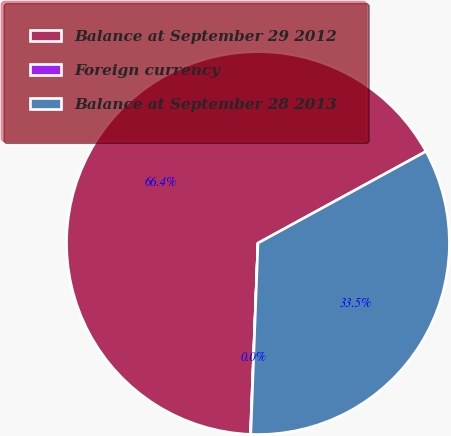Convert chart to OTSL. <chart><loc_0><loc_0><loc_500><loc_500><pie_chart><fcel>Balance at September 29 2012<fcel>Foreign currency<fcel>Balance at September 28 2013<nl><fcel>66.42%<fcel>0.03%<fcel>33.55%<nl></chart> 